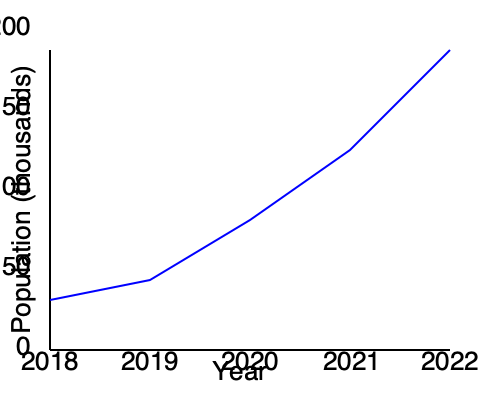As a local business owner and resource for expats, you're analyzing population growth trends in your city. The line graph shows the population growth from 2018 to 2022. What was the average annual population growth rate during this period, and how might this trend impact local businesses and services for expats? To answer this question, we need to follow these steps:

1. Determine the total population change:
   Initial population (2018): 50,000
   Final population (2022): 200,000
   Total change = 200,000 - 50,000 = 150,000

2. Calculate the average annual change:
   Number of years = 2022 - 2018 = 4 years
   Average annual change = 150,000 / 4 = 37,500

3. Calculate the average annual growth rate:
   Average annual growth rate = (Average annual change / Initial population) × 100
   = (37,500 / 50,000) × 100 = 75%

4. Analyze the impact on local businesses and services for expats:
   a) Increased demand for housing and real estate services
   b) Growth in consumer base for local businesses
   c) Higher demand for language schools and cultural integration services
   d) Potential strain on existing infrastructure and public services
   e) Opportunities for new businesses catering to diverse cultural needs
   f) Increased need for networking events and expat community services

The rapid population growth of 75% annually suggests a significant influx of new residents, likely including many expats. This presents both opportunities and challenges for local businesses and service providers catering to the expat community.
Answer: 75% average annual growth rate; increased demand for expat-oriented businesses and services, potential infrastructure strain 